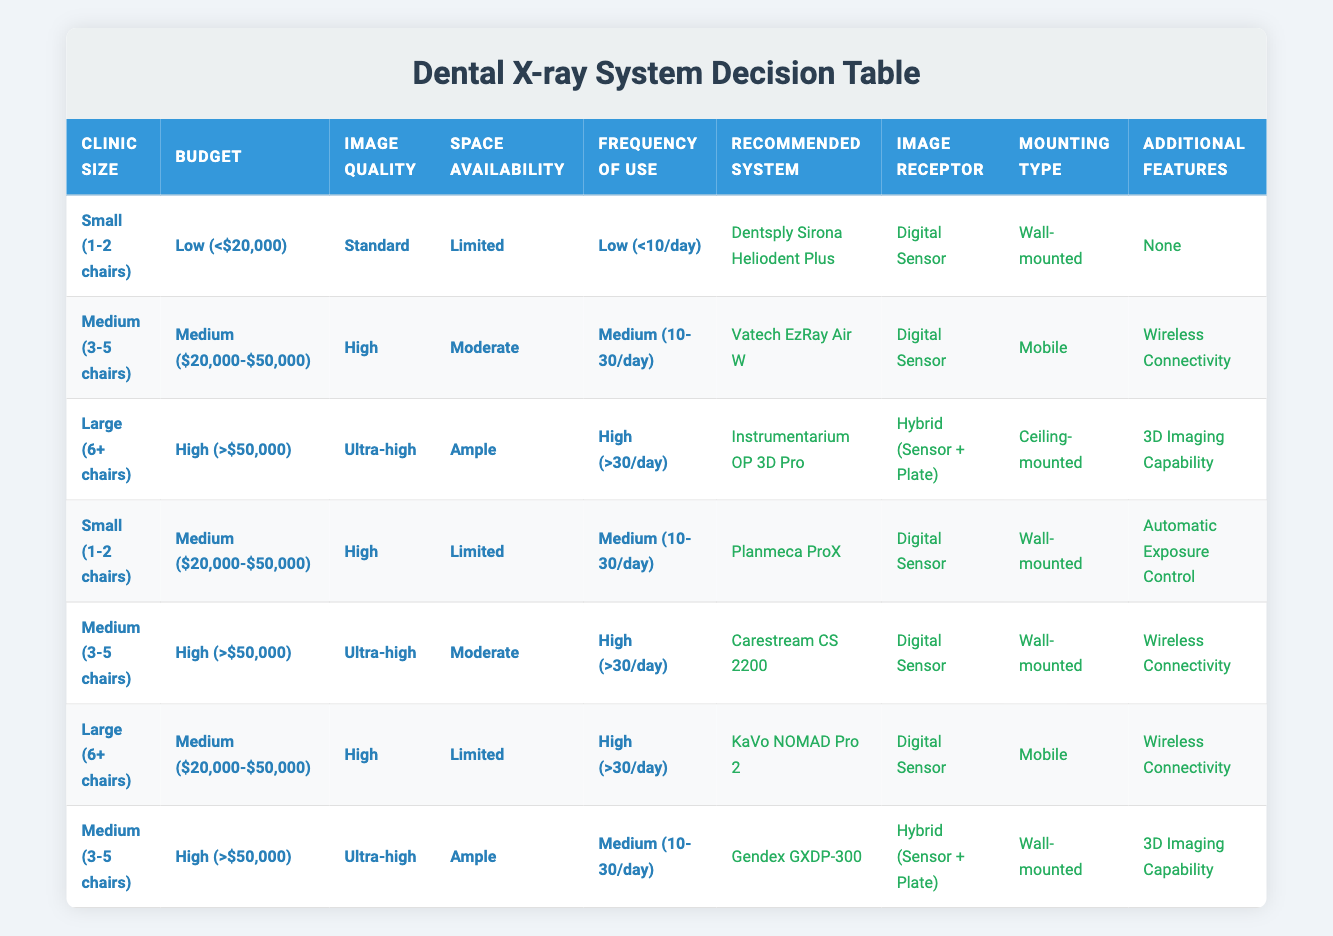What X-ray system is recommended for a medium-sized clinic with a medium budget and high image quality requirements? According to the table, a medium-sized clinic (3-5 chairs) with a medium budget ($20,000-$50,000) and high image quality requirements would recommend the Vatech EzRay Air W.
Answer: Vatech EzRay Air W Is the KaVo NOMAD Pro 2 recommended for a small clinic? The KaVo NOMAD Pro 2 is recommended for a large clinic (6+ chairs) with a medium budget ($20,000-$50,000). Therefore, it is not recommended for a small clinic.
Answer: No What type of image receptor is associated with the Instrumentarium OP 3D Pro? The table indicates that the Instrumentarium OP 3D Pro utilizes a hybrid image receptor type, which combines a sensor and a plate.
Answer: Hybrid (Sensor + Plate) How many recommended systems are there for clinics with a high frequency of use? The table shows 3 systems recommended for clinics with a high frequency of use (>30/day): Instrumentarium OP 3D Pro, Carestream CS 2200, and KaVo NOMAD Pro 2.
Answer: 3 Is there a system that features wireless connectivity and is wall-mounted? Yes, the Carestream CS 2200 includes wireless connectivity and is also wall-mounted according to the table.
Answer: Yes Which X-ray system has the highest budget requirement? The Instrumentarium OP 3D Pro is recommended for large clinics with a budget greater than $50,000, indicating it requires the highest budget according to the table.
Answer: Instrumentarium OP 3D Pro Based on the table, what is the recommended system for a small clinic with limited space and low frequency of use? For a small clinic (1-2 chairs) with a limited space and low frequency of use (<10/day), the Dentsply Sirona Heliodent Plus is recommended. This is derived directly from the conditions outlined in the rules.
Answer: Dentsply Sirona Heliodent Plus If a clinic wants to prioritize 3D imaging capabilities, what system should they choose? For 3D imaging capability, the Instrumentarium OP 3D Pro is the only system that includes this feature for large clinics; for medium clinics, the Gendex GXDP-300 also offers 3D imaging. Thus, they should choose either depending on their size.
Answer: Instrumentarium OP 3D Pro or Gendex GXDP-300 